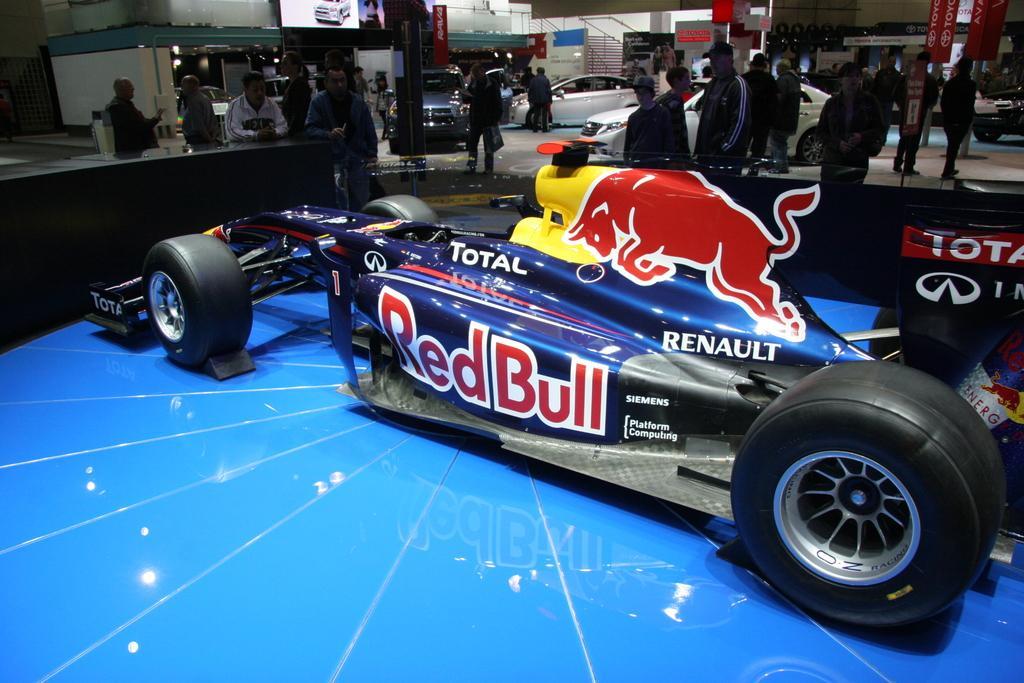Describe this image in one or two sentences. In this picture I can see the racing car which is placed on the blue color flooring. In the back I can see many person who are standing on the ground, beside them I can see some cars. On the right I can see the posters, banners and other objects. At the top I can see the stairs and railing. 